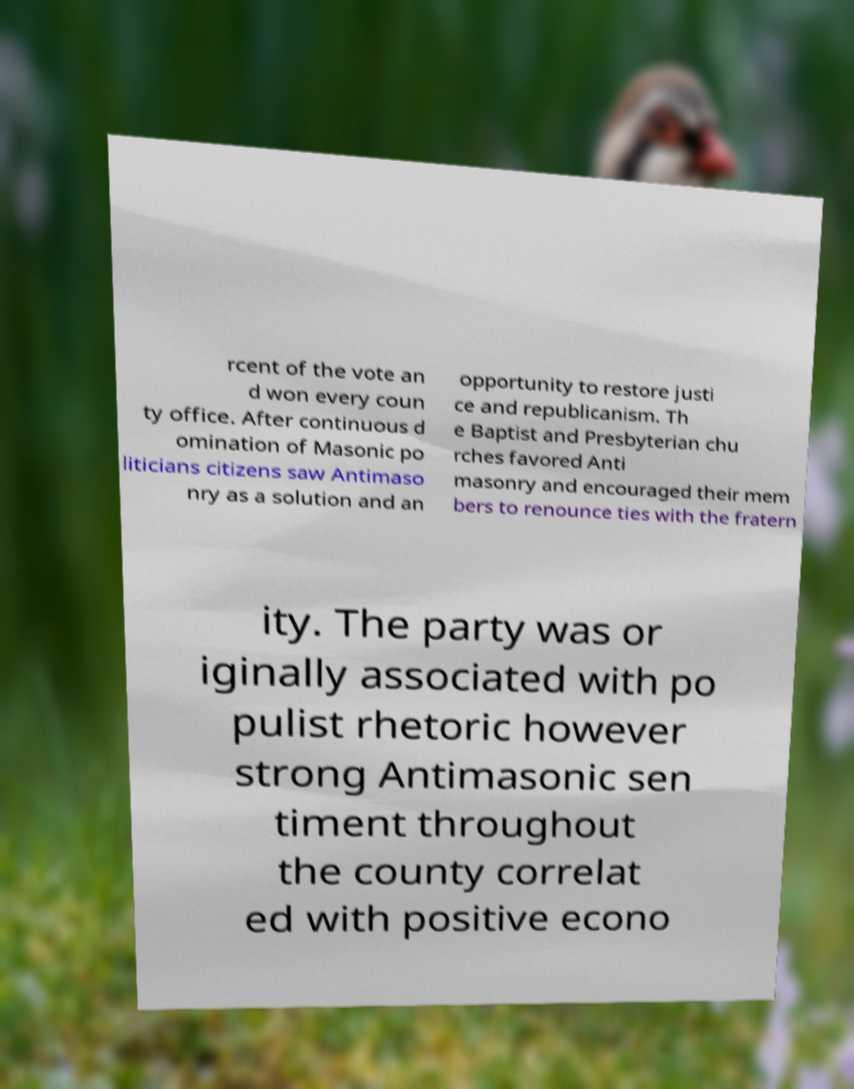Can you read and provide the text displayed in the image?This photo seems to have some interesting text. Can you extract and type it out for me? rcent of the vote an d won every coun ty office. After continuous d omination of Masonic po liticians citizens saw Antimaso nry as a solution and an opportunity to restore justi ce and republicanism. Th e Baptist and Presbyterian chu rches favored Anti masonry and encouraged their mem bers to renounce ties with the fratern ity. The party was or iginally associated with po pulist rhetoric however strong Antimasonic sen timent throughout the county correlat ed with positive econo 